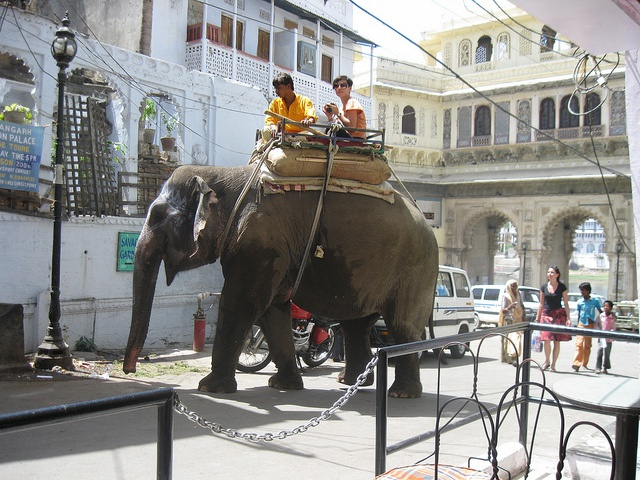Describe the objects in this image and their specific colors. I can see elephant in black and gray tones, car in black, lightgray, gray, and darkgray tones, motorcycle in black, gray, darkgray, and lightgray tones, people in black, red, maroon, and ivory tones, and people in black, gray, and tan tones in this image. 